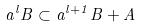Convert formula to latex. <formula><loc_0><loc_0><loc_500><loc_500>a ^ { l } B \subset a ^ { l + 1 } B + A</formula> 